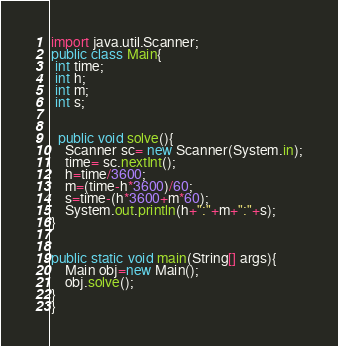<code> <loc_0><loc_0><loc_500><loc_500><_Java_>import java.util.Scanner;
public class Main{
 int time;
 int h;
 int m;
 int s;
 
  
  public void solve(){
    Scanner sc= new Scanner(System.in);
    time= sc.nextInt();
    h=time/3600;
    m=(time-h*3600)/60;
    s=time-(h*3600+m*60);
    System.out.println(h+":"+m+":"+s);
}


public static void main(String[] args){
    Main obj=new Main();
    obj.solve();
}
}</code> 